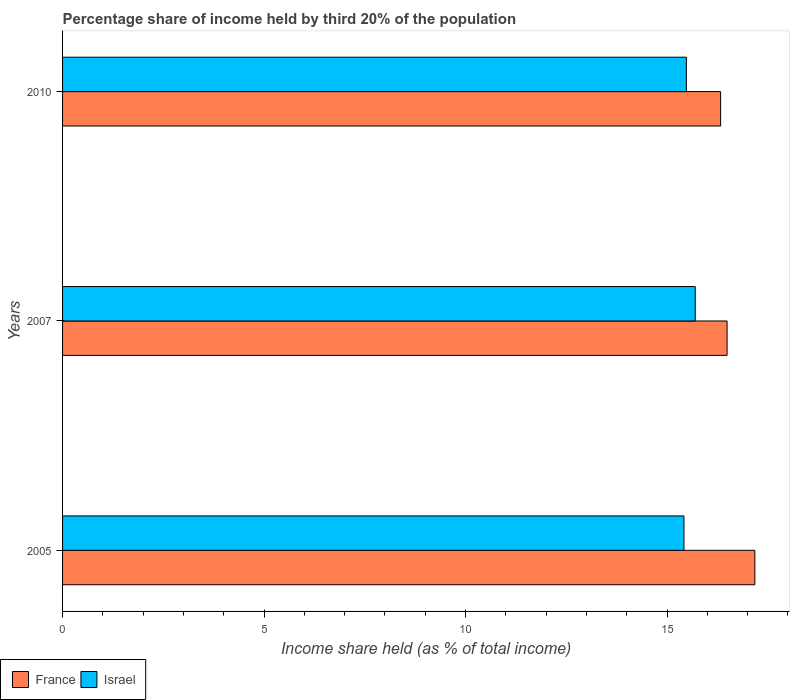How many different coloured bars are there?
Provide a short and direct response. 2. Are the number of bars per tick equal to the number of legend labels?
Keep it short and to the point. Yes. Are the number of bars on each tick of the Y-axis equal?
Give a very brief answer. Yes. How many bars are there on the 3rd tick from the bottom?
Give a very brief answer. 2. What is the label of the 3rd group of bars from the top?
Your response must be concise. 2005. What is the share of income held by third 20% of the population in Israel in 2010?
Provide a succinct answer. 15.48. Across all years, what is the maximum share of income held by third 20% of the population in Israel?
Your response must be concise. 15.7. Across all years, what is the minimum share of income held by third 20% of the population in France?
Your answer should be compact. 16.33. What is the total share of income held by third 20% of the population in Israel in the graph?
Provide a succinct answer. 46.6. What is the difference between the share of income held by third 20% of the population in Israel in 2005 and that in 2010?
Your response must be concise. -0.06. What is the difference between the share of income held by third 20% of the population in France in 2010 and the share of income held by third 20% of the population in Israel in 2005?
Offer a very short reply. 0.91. What is the average share of income held by third 20% of the population in France per year?
Provide a succinct answer. 16.67. In the year 2010, what is the difference between the share of income held by third 20% of the population in Israel and share of income held by third 20% of the population in France?
Offer a very short reply. -0.85. What is the ratio of the share of income held by third 20% of the population in Israel in 2005 to that in 2010?
Offer a very short reply. 1. Is the share of income held by third 20% of the population in Israel in 2005 less than that in 2010?
Your response must be concise. Yes. Is the difference between the share of income held by third 20% of the population in Israel in 2007 and 2010 greater than the difference between the share of income held by third 20% of the population in France in 2007 and 2010?
Provide a succinct answer. Yes. What is the difference between the highest and the second highest share of income held by third 20% of the population in Israel?
Give a very brief answer. 0.22. What is the difference between the highest and the lowest share of income held by third 20% of the population in Israel?
Your answer should be very brief. 0.28. Is the sum of the share of income held by third 20% of the population in Israel in 2007 and 2010 greater than the maximum share of income held by third 20% of the population in France across all years?
Make the answer very short. Yes. Are all the bars in the graph horizontal?
Ensure brevity in your answer.  Yes. What is the difference between two consecutive major ticks on the X-axis?
Your answer should be very brief. 5. Are the values on the major ticks of X-axis written in scientific E-notation?
Your answer should be very brief. No. Does the graph contain any zero values?
Your answer should be very brief. No. Where does the legend appear in the graph?
Offer a terse response. Bottom left. How are the legend labels stacked?
Offer a terse response. Horizontal. What is the title of the graph?
Provide a succinct answer. Percentage share of income held by third 20% of the population. What is the label or title of the X-axis?
Provide a short and direct response. Income share held (as % of total income). What is the label or title of the Y-axis?
Provide a short and direct response. Years. What is the Income share held (as % of total income) of France in 2005?
Ensure brevity in your answer.  17.18. What is the Income share held (as % of total income) of Israel in 2005?
Offer a very short reply. 15.42. What is the Income share held (as % of total income) in France in 2007?
Your response must be concise. 16.49. What is the Income share held (as % of total income) in France in 2010?
Keep it short and to the point. 16.33. What is the Income share held (as % of total income) in Israel in 2010?
Make the answer very short. 15.48. Across all years, what is the maximum Income share held (as % of total income) in France?
Ensure brevity in your answer.  17.18. Across all years, what is the maximum Income share held (as % of total income) in Israel?
Your answer should be compact. 15.7. Across all years, what is the minimum Income share held (as % of total income) of France?
Your answer should be compact. 16.33. Across all years, what is the minimum Income share held (as % of total income) in Israel?
Your answer should be very brief. 15.42. What is the total Income share held (as % of total income) of Israel in the graph?
Your answer should be compact. 46.6. What is the difference between the Income share held (as % of total income) of France in 2005 and that in 2007?
Keep it short and to the point. 0.69. What is the difference between the Income share held (as % of total income) of Israel in 2005 and that in 2007?
Make the answer very short. -0.28. What is the difference between the Income share held (as % of total income) in France in 2005 and that in 2010?
Offer a terse response. 0.85. What is the difference between the Income share held (as % of total income) in Israel in 2005 and that in 2010?
Provide a short and direct response. -0.06. What is the difference between the Income share held (as % of total income) in France in 2007 and that in 2010?
Provide a short and direct response. 0.16. What is the difference between the Income share held (as % of total income) of Israel in 2007 and that in 2010?
Your answer should be very brief. 0.22. What is the difference between the Income share held (as % of total income) in France in 2005 and the Income share held (as % of total income) in Israel in 2007?
Offer a terse response. 1.48. What is the difference between the Income share held (as % of total income) of France in 2005 and the Income share held (as % of total income) of Israel in 2010?
Offer a terse response. 1.7. What is the difference between the Income share held (as % of total income) in France in 2007 and the Income share held (as % of total income) in Israel in 2010?
Make the answer very short. 1.01. What is the average Income share held (as % of total income) in France per year?
Provide a succinct answer. 16.67. What is the average Income share held (as % of total income) in Israel per year?
Offer a terse response. 15.53. In the year 2005, what is the difference between the Income share held (as % of total income) of France and Income share held (as % of total income) of Israel?
Give a very brief answer. 1.76. In the year 2007, what is the difference between the Income share held (as % of total income) of France and Income share held (as % of total income) of Israel?
Your answer should be very brief. 0.79. What is the ratio of the Income share held (as % of total income) in France in 2005 to that in 2007?
Offer a very short reply. 1.04. What is the ratio of the Income share held (as % of total income) of Israel in 2005 to that in 2007?
Your answer should be very brief. 0.98. What is the ratio of the Income share held (as % of total income) of France in 2005 to that in 2010?
Your response must be concise. 1.05. What is the ratio of the Income share held (as % of total income) in Israel in 2005 to that in 2010?
Provide a short and direct response. 1. What is the ratio of the Income share held (as % of total income) in France in 2007 to that in 2010?
Offer a terse response. 1.01. What is the ratio of the Income share held (as % of total income) of Israel in 2007 to that in 2010?
Offer a terse response. 1.01. What is the difference between the highest and the second highest Income share held (as % of total income) in France?
Offer a terse response. 0.69. What is the difference between the highest and the second highest Income share held (as % of total income) in Israel?
Offer a very short reply. 0.22. What is the difference between the highest and the lowest Income share held (as % of total income) of Israel?
Ensure brevity in your answer.  0.28. 